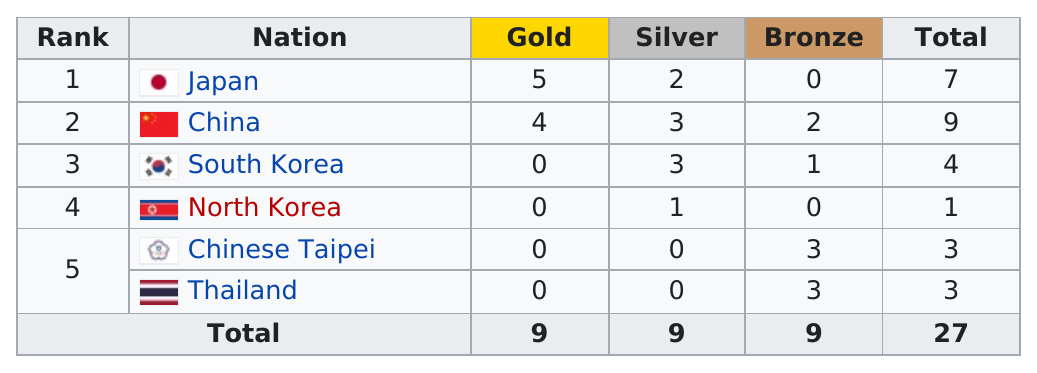Mention a couple of crucial points in this snapshot. According to the information provided, China won more total medals than Japan. North Korea placed last in the overall medal count in the competition. Japan earned more gold medals than Thailand by a margin of 5. Thailand is the nation that earned the most bronze medals, as compared to South Korea. A total of 27 medals were awarded. 